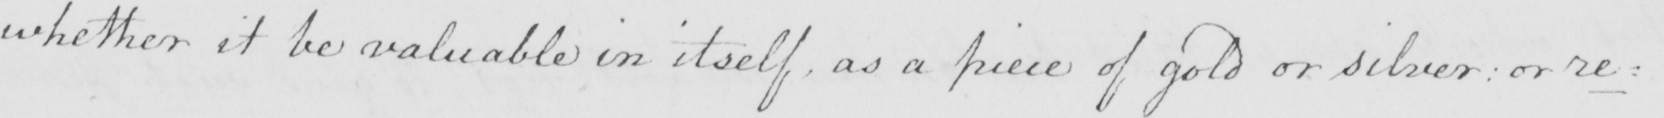Can you tell me what this handwritten text says? whether it be valuable in itself , as a piece of gold or silver :  or re : 